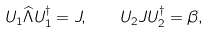Convert formula to latex. <formula><loc_0><loc_0><loc_500><loc_500>U _ { 1 } \widehat { \Lambda } U _ { 1 } ^ { \dagger } = J , \quad U _ { 2 } J U _ { 2 } ^ { \dagger } = \beta ,</formula> 